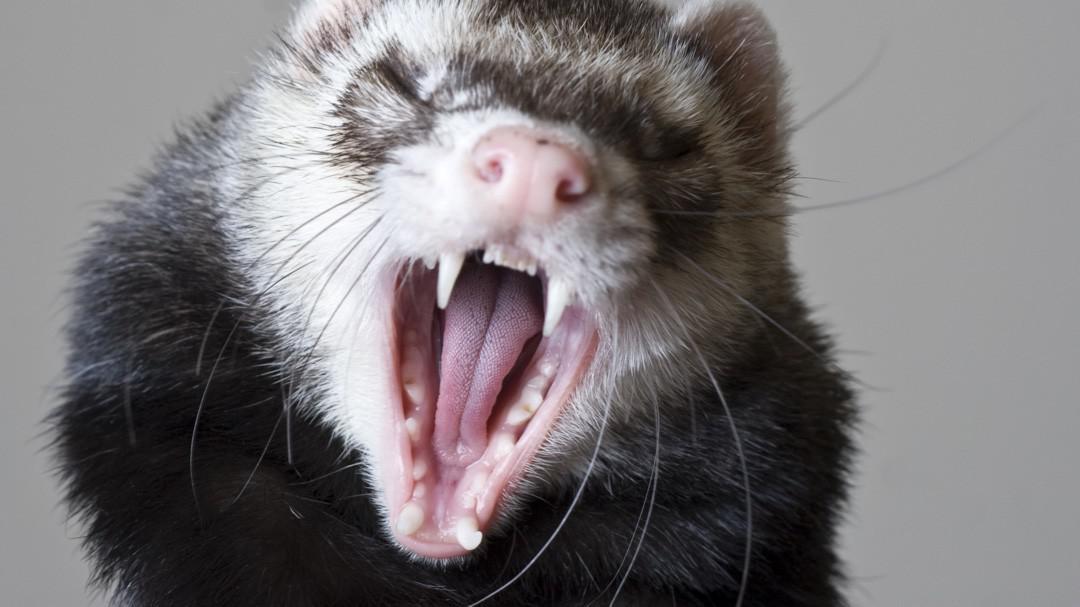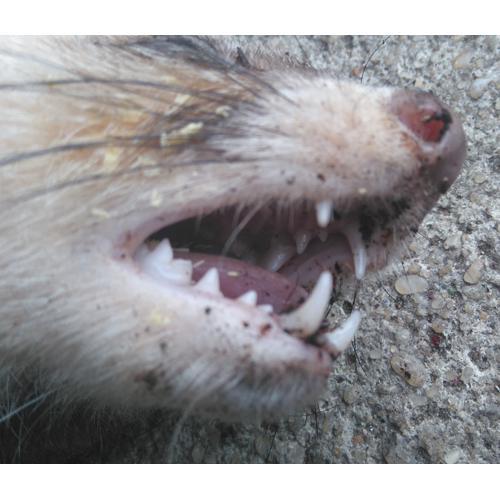The first image is the image on the left, the second image is the image on the right. Analyze the images presented: Is the assertion "Someone is holding the animal." valid? Answer yes or no. No. 